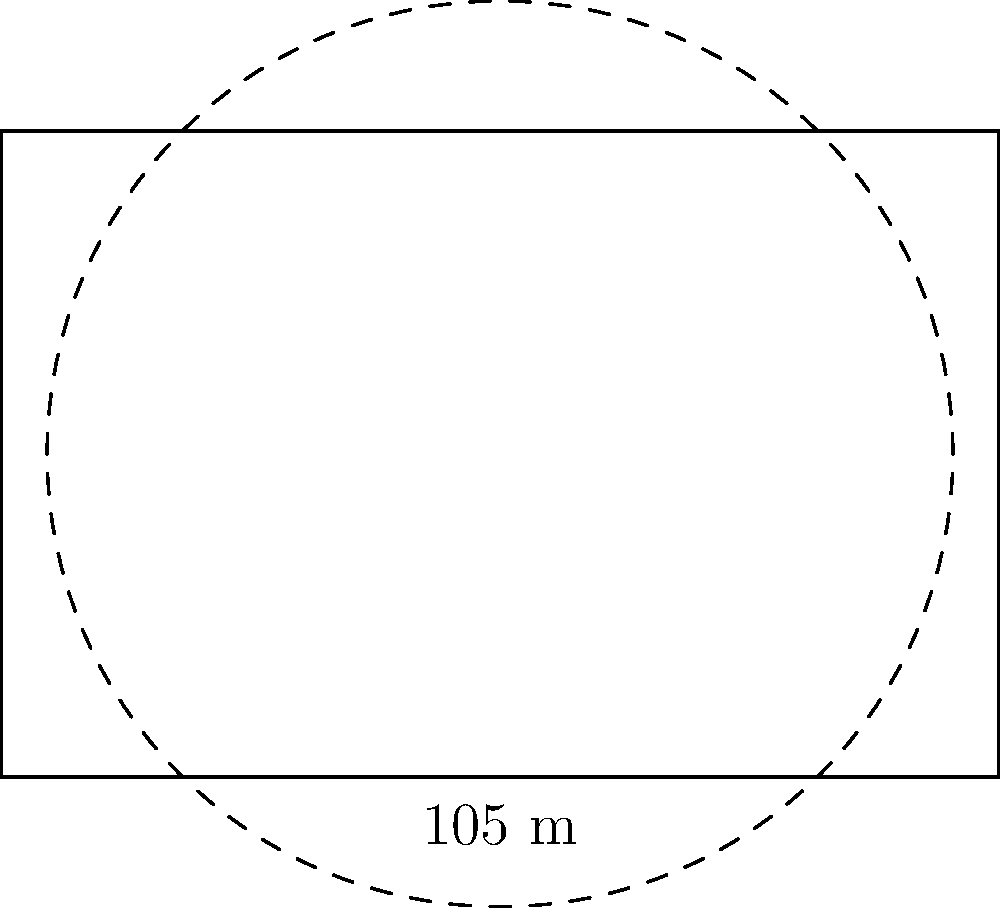As a dedicated AS Monaco FC fan, you know that the Stade Louis II pitch measures 105 meters by 68 meters. If a circle had the same area as the pitch, what would be its circumference? Round your answer to the nearest meter. Let's approach this step-by-step:

1) First, we need to calculate the area of the Stade Louis II pitch:
   $A_{pitch} = 105 \text{ m} \times 68 \text{ m} = 7,140 \text{ m}^2$

2) Now, we know that this area is equal to the area of our circle. The formula for the area of a circle is:
   $A_{circle} = \pi r^2$

3) We can set up an equation:
   $7,140 = \pi r^2$

4) Solving for $r$:
   $r^2 = \frac{7,140}{\pi}$
   $r = \sqrt{\frac{7,140}{\pi}} \approx 47.6 \text{ m}$

5) Now that we have the radius, we can calculate the circumference using the formula:
   $C = 2\pi r$

6) Plugging in our value for $r$:
   $C = 2\pi(47.6) \approx 299.1 \text{ m}$

7) Rounding to the nearest meter:
   $C \approx 299 \text{ m}$
Answer: 299 m 